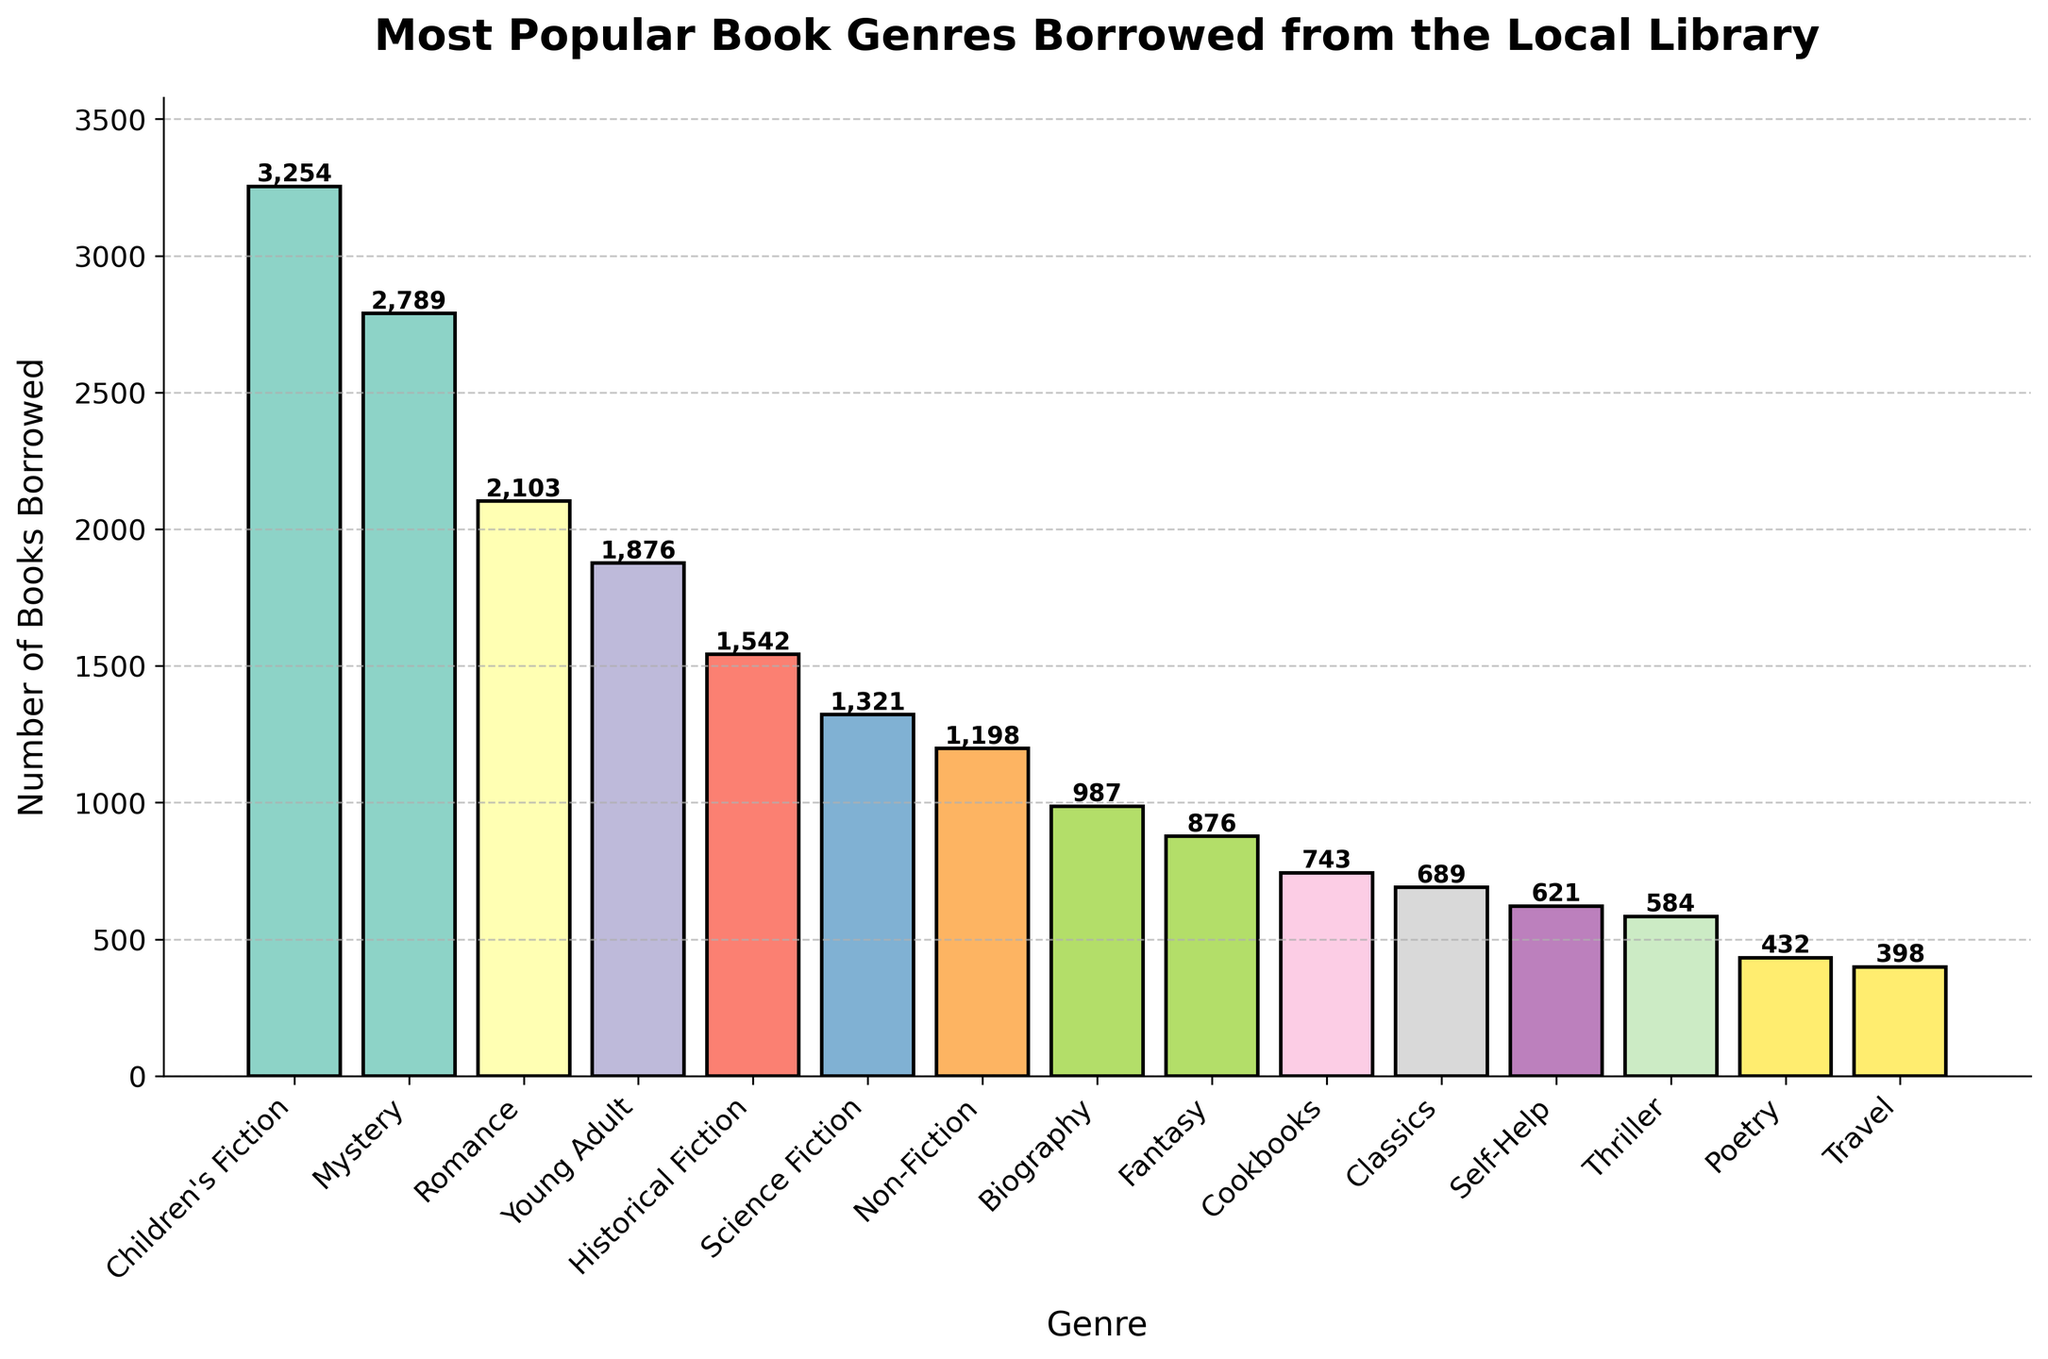Which genre has the highest number of books borrowed? The tallest bar represents the genre with the highest number of books borrowed. In this case, Children's Fiction has the tallest bar.
Answer: Children's Fiction Which genre has the lowest number of books borrowed? The shortest bar represents the genre with the lowest number of books borrowed. Here, Travel has the shortest bar.
Answer: Travel Which two genres combined have a total borrowed count nearest to 3000? To find this, we need to verify the combined borrowed counts of all pairs and check which pair sums to approximately 3000. Mystery (2789) and Travel (398) together total 3187, the closest sum to 3000.
Answer: Mystery and Travel How much more popular is Mystery compared to Thriller, in terms of borrowed count? To find this, subtract the borrowed count of Thriller from Mystery. Mystery has 2789 borrowed counts and Thriller has 584. Thus, 2789 - 584 = 2205.
Answer: 2205 What is the median borrowed count among all genres? To find the median, list all borrowed counts in ascending order and find the middle value. The borrowed counts in ascending order are: 398, 432, 584, 621, 689, 743, 876, 987, 1198, 1321, 1542, 1876, 2103, 2789, 3254. The median value, being the 8th in order, is 987.
Answer: 987 Are Romance books more popular than Non-Fiction books? Compare the borrowed counts of Romance and Non-Fiction. Romance has 2103 borrowed counts, while Non-Fiction has 1198. Since 2103 is greater than 1198, Romance is more popular.
Answer: Yes Which genres have borrowed counts between 1000 and 2000? Look for bars with heights corresponding to borrowed counts within this range. Young Adult (1876), Historical Fiction (1542), and Science Fiction (1321) fit this criterion.
Answer: Young Adult, Historical Fiction, Science Fiction What is the total number of borrowed counts for all genres combined? Sum all borrowed counts: 3254 + 2789 + 2103 + 1876 + 1542 + 1321 + 1198 + 987 + 876 + 743 + 689 + 621 + 584 + 432 + 398 = 18913.
Answer: 18913 How does the color of the Self-Help genre bar compare to the color of the Mystery genre bar? Self-Help genre is several shades of a pastel color set, making it distinct from Mystery. Visually, the Self-Help bar is lighter compared to Mystery. Both bars are part of a color palette but the Mystery genre bar is perceptibly darker.
Answer: Self-Help is lighter than Mystery 